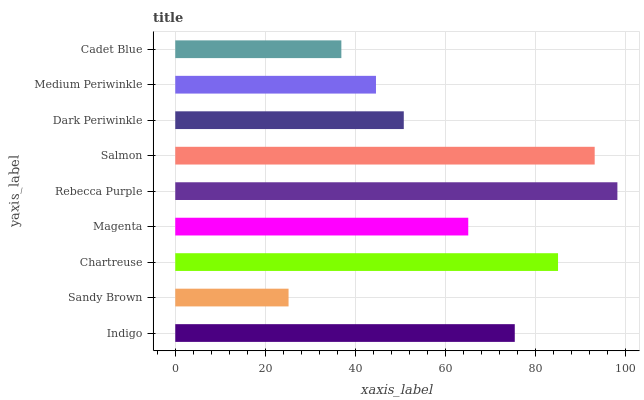Is Sandy Brown the minimum?
Answer yes or no. Yes. Is Rebecca Purple the maximum?
Answer yes or no. Yes. Is Chartreuse the minimum?
Answer yes or no. No. Is Chartreuse the maximum?
Answer yes or no. No. Is Chartreuse greater than Sandy Brown?
Answer yes or no. Yes. Is Sandy Brown less than Chartreuse?
Answer yes or no. Yes. Is Sandy Brown greater than Chartreuse?
Answer yes or no. No. Is Chartreuse less than Sandy Brown?
Answer yes or no. No. Is Magenta the high median?
Answer yes or no. Yes. Is Magenta the low median?
Answer yes or no. Yes. Is Medium Periwinkle the high median?
Answer yes or no. No. Is Dark Periwinkle the low median?
Answer yes or no. No. 